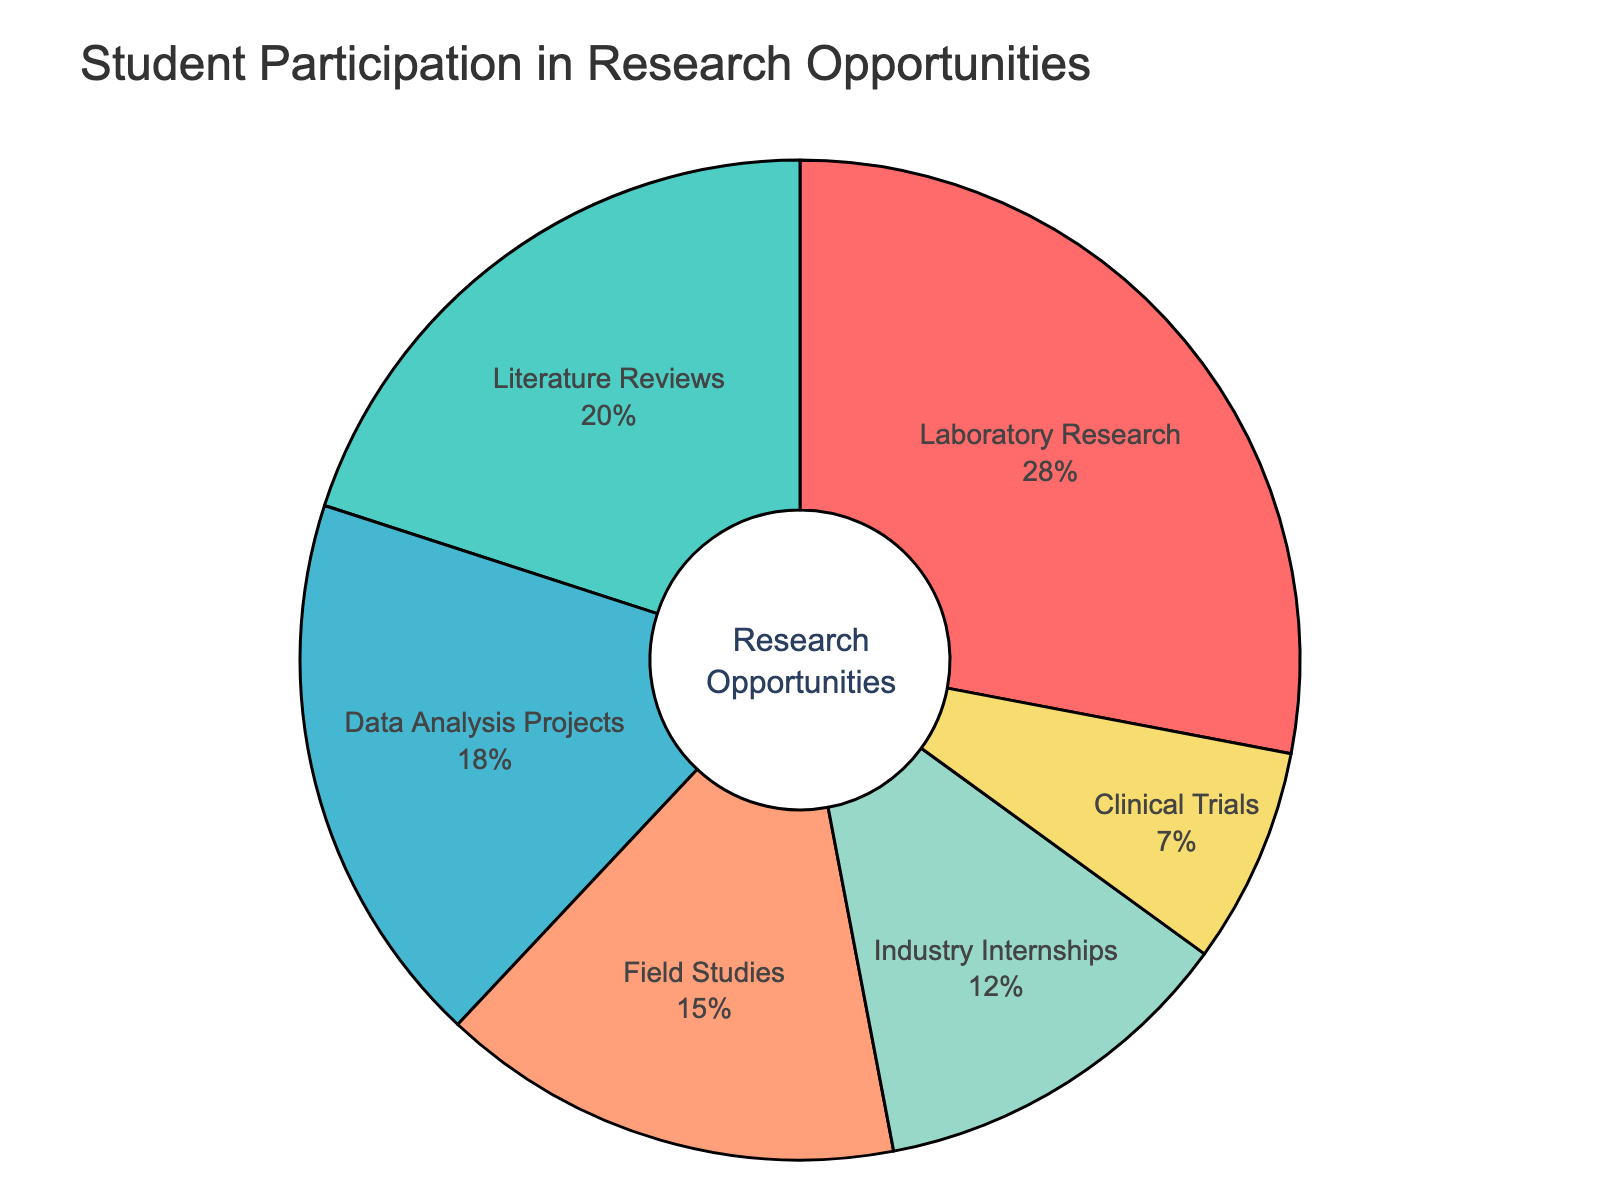Which research type has the highest student participation? The pie chart shows the percentage distribution of students participating in various research types. By observing the chart, it is evident that Laboratory Research has the largest section.
Answer: Laboratory Research Which research type has the lowest student participation? By looking at the pie chart, Clinical Trials have the smallest section, indicating the lowest participation.
Answer: Clinical Trials What is the difference in student participation between Laboratory Research and Industry Internships? Laboratory Research has 28% of participation and Industry Internships have 12%. The difference is calculated as 28% - 12% = 16%.
Answer: 16% What is the combined percentage of students participating in Literature Reviews and Data Analysis Projects? Literature Reviews have 20% and Data Analysis Projects have 18%. The combined percentage is 20% + 18% = 38%.
Answer: 38% Compare the student participation in Field Studies and Clinical Trials. Which research type has more participation and by how much? Field Studies have 15% participation and Clinical Trials have 7%. Field Studies have a higher participation by 15% - 7% = 8%.
Answer: Field Studies by 8% Which research type represented by the blue section in the pie chart? By identifying the colors used in the sections of the pie chart, Data Analysis Projects is represented by the blue section.
Answer: Data Analysis Projects How does the participation in Field Studies compare to Literature Reviews? Field Studies have 15% participation whereas Literature Reviews have 20%. Therefore, Literature Reviews have a higher participation by 5%.
Answer: Literature Reviews by 5% What percentage of students participate in research types other than Laboratory Research? The participation for Laboratory Research is 28%. Therefore, the percentage for other research types is 100% - 28% = 72%.
Answer: 72% Which research types have a participation percentage above 15%? By observing the pie chart, Laboratory Research (28%), Literature Reviews (20%), and Data Analysis Projects (18%) have participation percentages above 15%.
Answer: Laboratory Research, Literature Reviews, Data Analysis Projects 